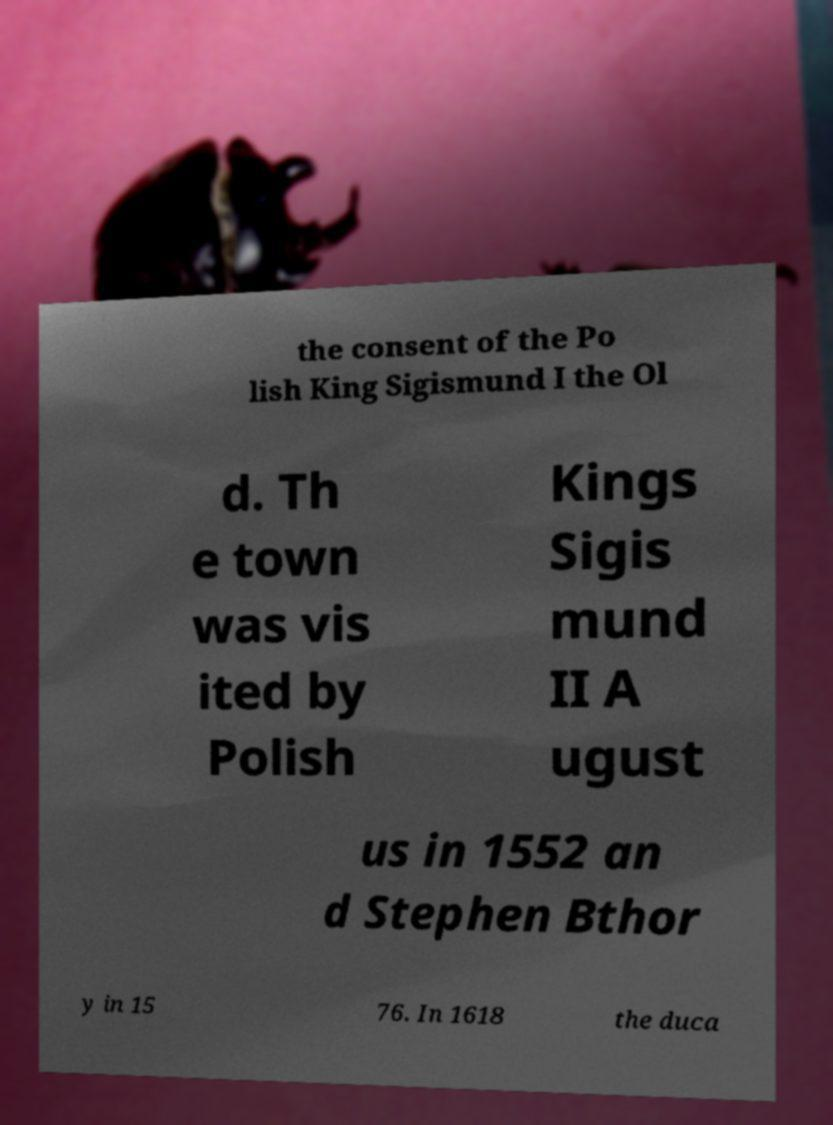There's text embedded in this image that I need extracted. Can you transcribe it verbatim? the consent of the Po lish King Sigismund I the Ol d. Th e town was vis ited by Polish Kings Sigis mund II A ugust us in 1552 an d Stephen Bthor y in 15 76. In 1618 the duca 